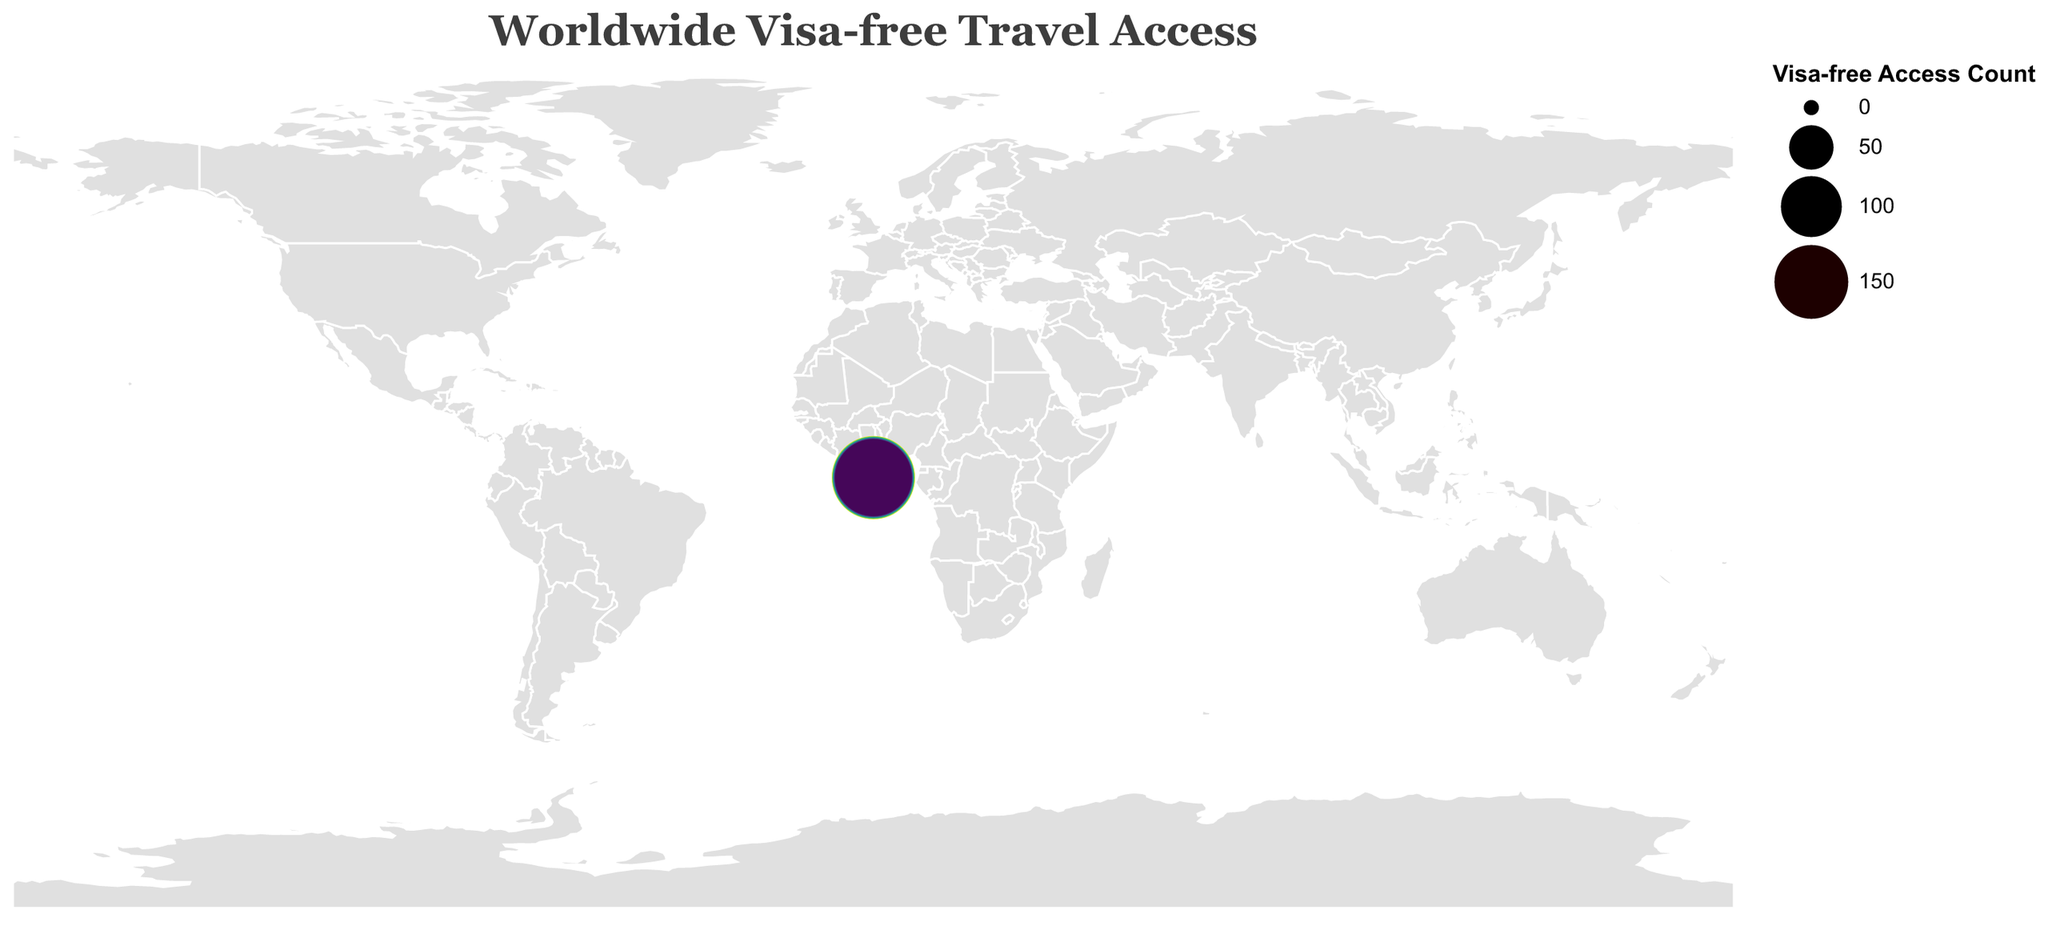What's the title of the figure? The title is typically found at the top of the figure and gives a summary of what the figure represents. In this case, it indicates the main idea behind the visualization.
Answer: Worldwide Visa-free Travel Access How many countries have over 180 visa-free access? Count the number of entries where the Visa-free Access Count is greater than 180.
Answer: 13 Which country has the highest number of visa-free access? Identify the country with the highest value in the Visa-free Access Count column.
Answer: Japan What is the visa-free access count for Germany compared to Canada? Compare the values in the Visa-free Access Count column for Germany and Canada. Germany has a count of 190 and Canada has 171.
Answer: Germany has 19 more visa-free access than Canada Which country has the lowest number of visa-free access among the listed countries? Identify the country with the smallest value in the Visa-free Access Count column.
Answer: Latvia How many European countries are in the top 10 for visa-free travel access? Identify and count the European countries within the top 10 by visa-free access count. European countries include Germany, Spain, Finland, Italy, Luxembourg, Austria, Denmark, and Netherlands.
Answer: 8 Is the United States among the top 15 countries with the most visa-free travel access? Check if the United States is listed in the top 15 entries of the Visa-free Access Count.
Answer: No What's the difference in visa-free access between Japan and the United Kingdom? Subtract the Visa-free Access Count of the United Kingdom from Japan's count. 193 - 177 = 16.
Answer: 16 How do the visa-free access counts of Australia and New Zealand compare? Compare the Visa-free Access Counts for Australia (173) and New Zealand (172).
Answer: Australia has 1 more visa-free access than New Zealand Among the listed countries, which region has the most representation in terms of countries listed? Group the countries by region (Asia, Europe, Americas, etc.) and count the entries. Europe has the most with 19 countries.
Answer: Europe 